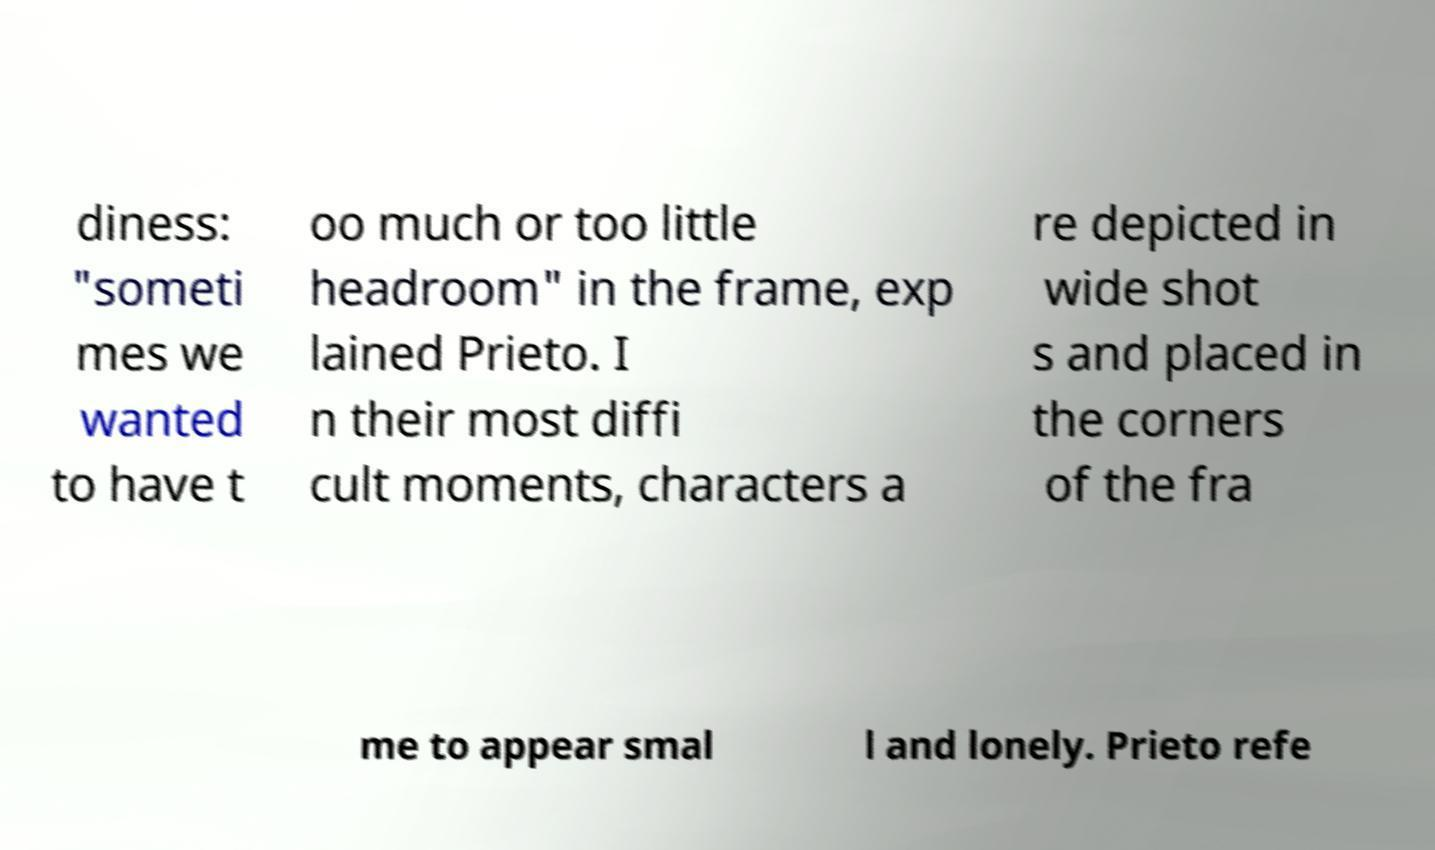Can you accurately transcribe the text from the provided image for me? diness: "someti mes we wanted to have t oo much or too little headroom" in the frame, exp lained Prieto. I n their most diffi cult moments, characters a re depicted in wide shot s and placed in the corners of the fra me to appear smal l and lonely. Prieto refe 